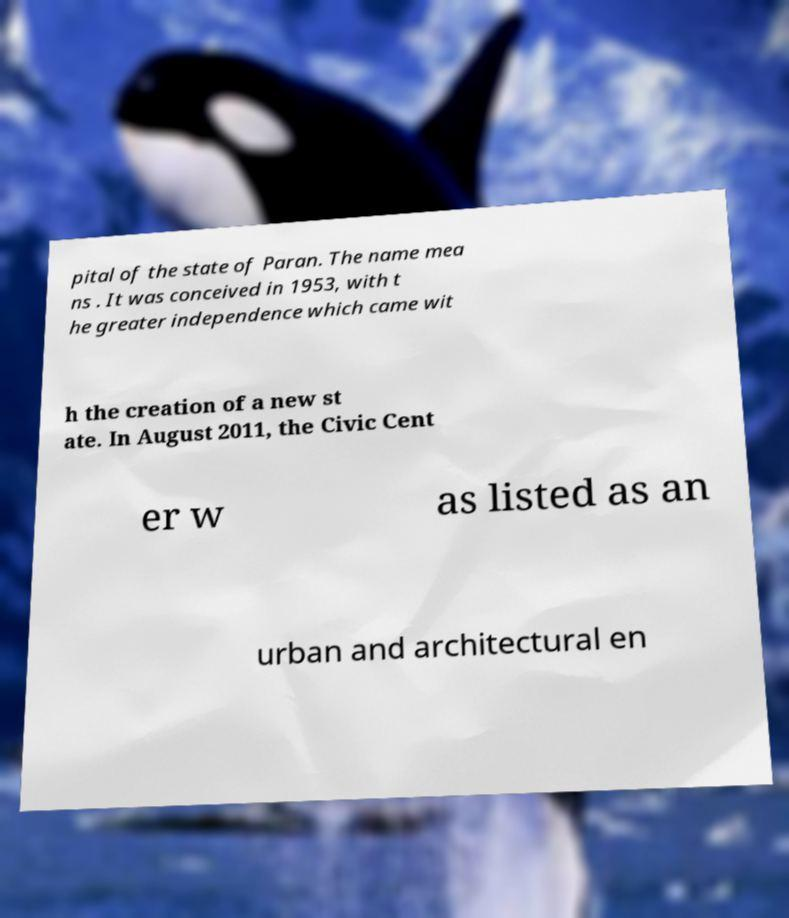For documentation purposes, I need the text within this image transcribed. Could you provide that? pital of the state of Paran. The name mea ns . It was conceived in 1953, with t he greater independence which came wit h the creation of a new st ate. In August 2011, the Civic Cent er w as listed as an urban and architectural en 